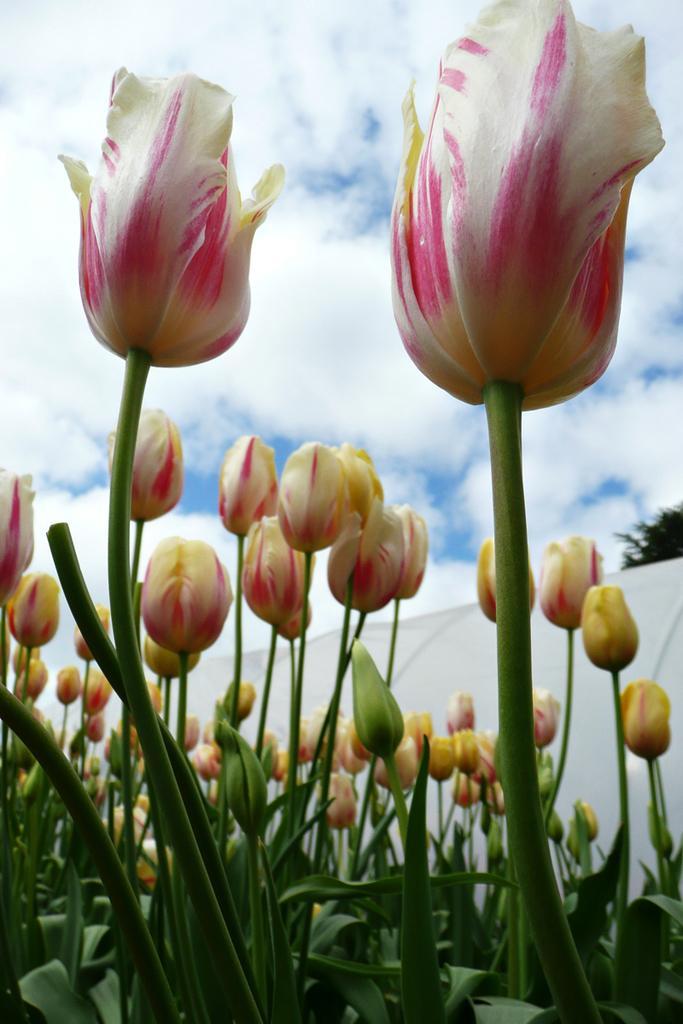Describe this image in one or two sentences. In this image, we can see some buds and leaves. There are clouds in the sky. There is a cloth in the middle of the image. 